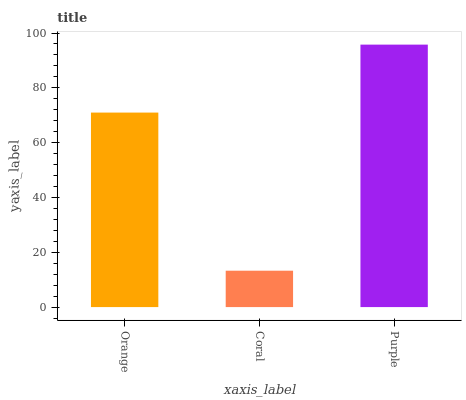Is Coral the minimum?
Answer yes or no. Yes. Is Purple the maximum?
Answer yes or no. Yes. Is Purple the minimum?
Answer yes or no. No. Is Coral the maximum?
Answer yes or no. No. Is Purple greater than Coral?
Answer yes or no. Yes. Is Coral less than Purple?
Answer yes or no. Yes. Is Coral greater than Purple?
Answer yes or no. No. Is Purple less than Coral?
Answer yes or no. No. Is Orange the high median?
Answer yes or no. Yes. Is Orange the low median?
Answer yes or no. Yes. Is Purple the high median?
Answer yes or no. No. Is Coral the low median?
Answer yes or no. No. 